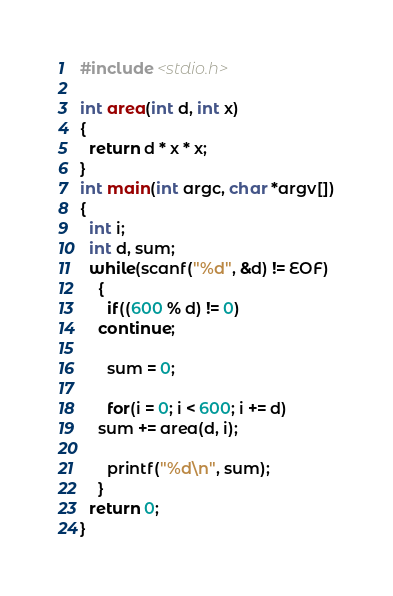<code> <loc_0><loc_0><loc_500><loc_500><_C_>#include <stdio.h>

int area(int d, int x)
{
  return d * x * x;
}
int main(int argc, char *argv[])
{
  int i;
  int d, sum;
  while(scanf("%d", &d) != EOF)
    {
      if((600 % d) != 0)
	continue;
      
      sum = 0;
      
      for(i = 0; i < 600; i += d)
	sum += area(d, i);
      
      printf("%d\n", sum);
    }
  return 0;
}</code> 